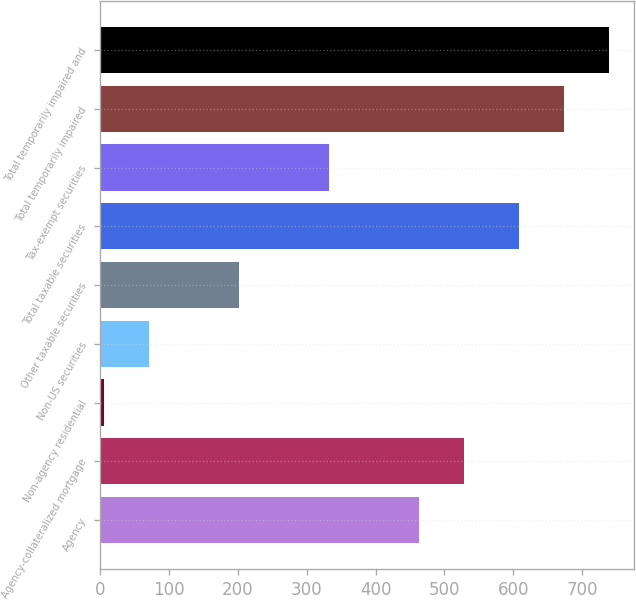Convert chart. <chart><loc_0><loc_0><loc_500><loc_500><bar_chart><fcel>Agency<fcel>Agency-collateralized mortgage<fcel>Non-agency residential<fcel>Non-US securities<fcel>Other taxable securities<fcel>Total taxable securities<fcel>Tax-exempt securities<fcel>Total temporarily impaired<fcel>Total temporarily impaired and<nl><fcel>463.5<fcel>529<fcel>5<fcel>70.5<fcel>201.5<fcel>608<fcel>332.5<fcel>673.5<fcel>739<nl></chart> 